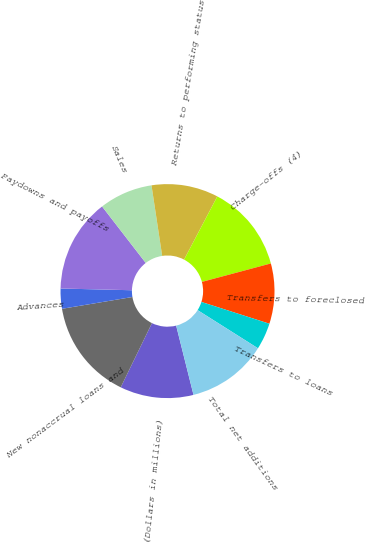<chart> <loc_0><loc_0><loc_500><loc_500><pie_chart><fcel>(Dollars in millions)<fcel>New nonaccrual loans and<fcel>Advances<fcel>Paydowns and payoffs<fcel>Sales<fcel>Returns to performing status<fcel>Charge-offs (4)<fcel>Transfers to foreclosed<fcel>Transfers to loans<fcel>Total net additions<nl><fcel>11.11%<fcel>15.15%<fcel>3.03%<fcel>14.14%<fcel>8.08%<fcel>10.1%<fcel>13.13%<fcel>9.09%<fcel>4.04%<fcel>12.12%<nl></chart> 